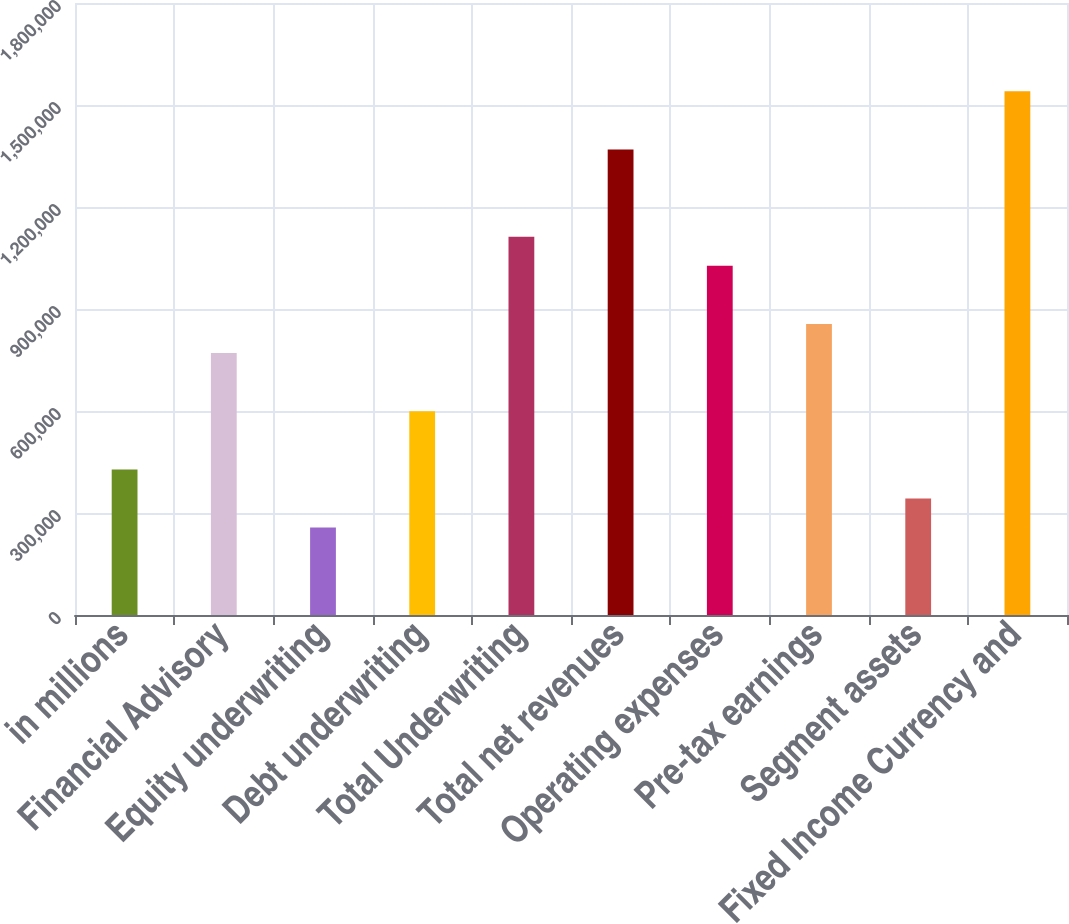Convert chart. <chart><loc_0><loc_0><loc_500><loc_500><bar_chart><fcel>in millions<fcel>Financial Advisory<fcel>Equity underwriting<fcel>Debt underwriting<fcel>Total Underwriting<fcel>Total net revenues<fcel>Operating expenses<fcel>Pre-tax earnings<fcel>Segment assets<fcel>Fixed Income Currency and<nl><fcel>428154<fcel>770304<fcel>257079<fcel>599229<fcel>1.11245e+06<fcel>1.36907e+06<fcel>1.02692e+06<fcel>855842<fcel>342616<fcel>1.54014e+06<nl></chart> 